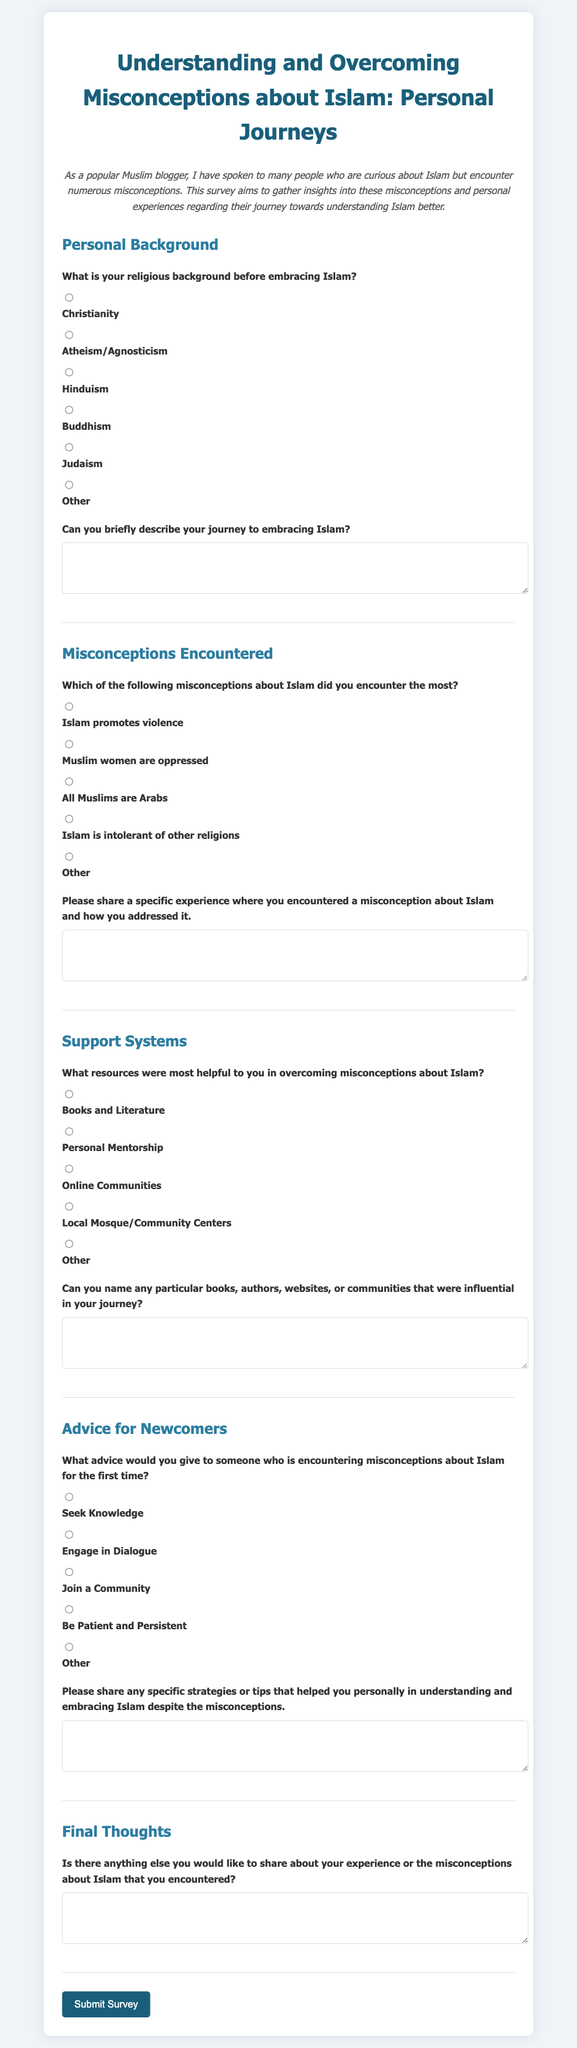What is the title of the survey? The title of the survey is given in the header section of the document.
Answer: Understanding and Overcoming Misconceptions about Islam: Personal Journeys What is the purpose of this survey? The purpose is stated in the introductory paragraph of the document, focusing on gathering insights about misconceptions regarding Islam.
Answer: To gather insights into misconceptions and personal experiences regarding their journey towards understanding Islam better What options are available for the religious background question? The document lists various options within the personal background section related to prior religious affiliations.
Answer: Christianity, Atheism/Agnosticism, Hinduism, Buddhism, Judaism, Other What are some misconceptions listed that individuals may encounter? The misconceptions are highlighted in the relevant section of the survey, enumerating common false beliefs about Islam.
Answer: Islam promotes violence, Muslim women are oppressed, All Muslims are Arabs, Islam is intolerant of other religions, Other Which resources are mentioned as helpful for overcoming misconceptions? The document presents options in the support systems section that people found useful in their journey.
Answer: Books and Literature, Personal Mentorship, Online Communities, Local Mosque/Community Centers, Other What advice is given for newcomers encountering misconceptions? The survey includes a question about advice to newcomers, providing multiple-choice options for guidance.
Answer: Seek Knowledge, Engage in Dialogue, Join a Community, Be Patient and Persistent, Other What is the final section of the survey about? The structure of the survey includes a designated area at the end for sharing overall thoughts.
Answer: Final Thoughts How is the information submitted in the survey? The submission method is indicated by the final button provided in the document.
Answer: Submit Survey What format does the survey utilize for gathering responses? The survey uses checkboxes and text areas for gathering individual feedback in a structured manner.
Answer: Radio buttons and text areas 